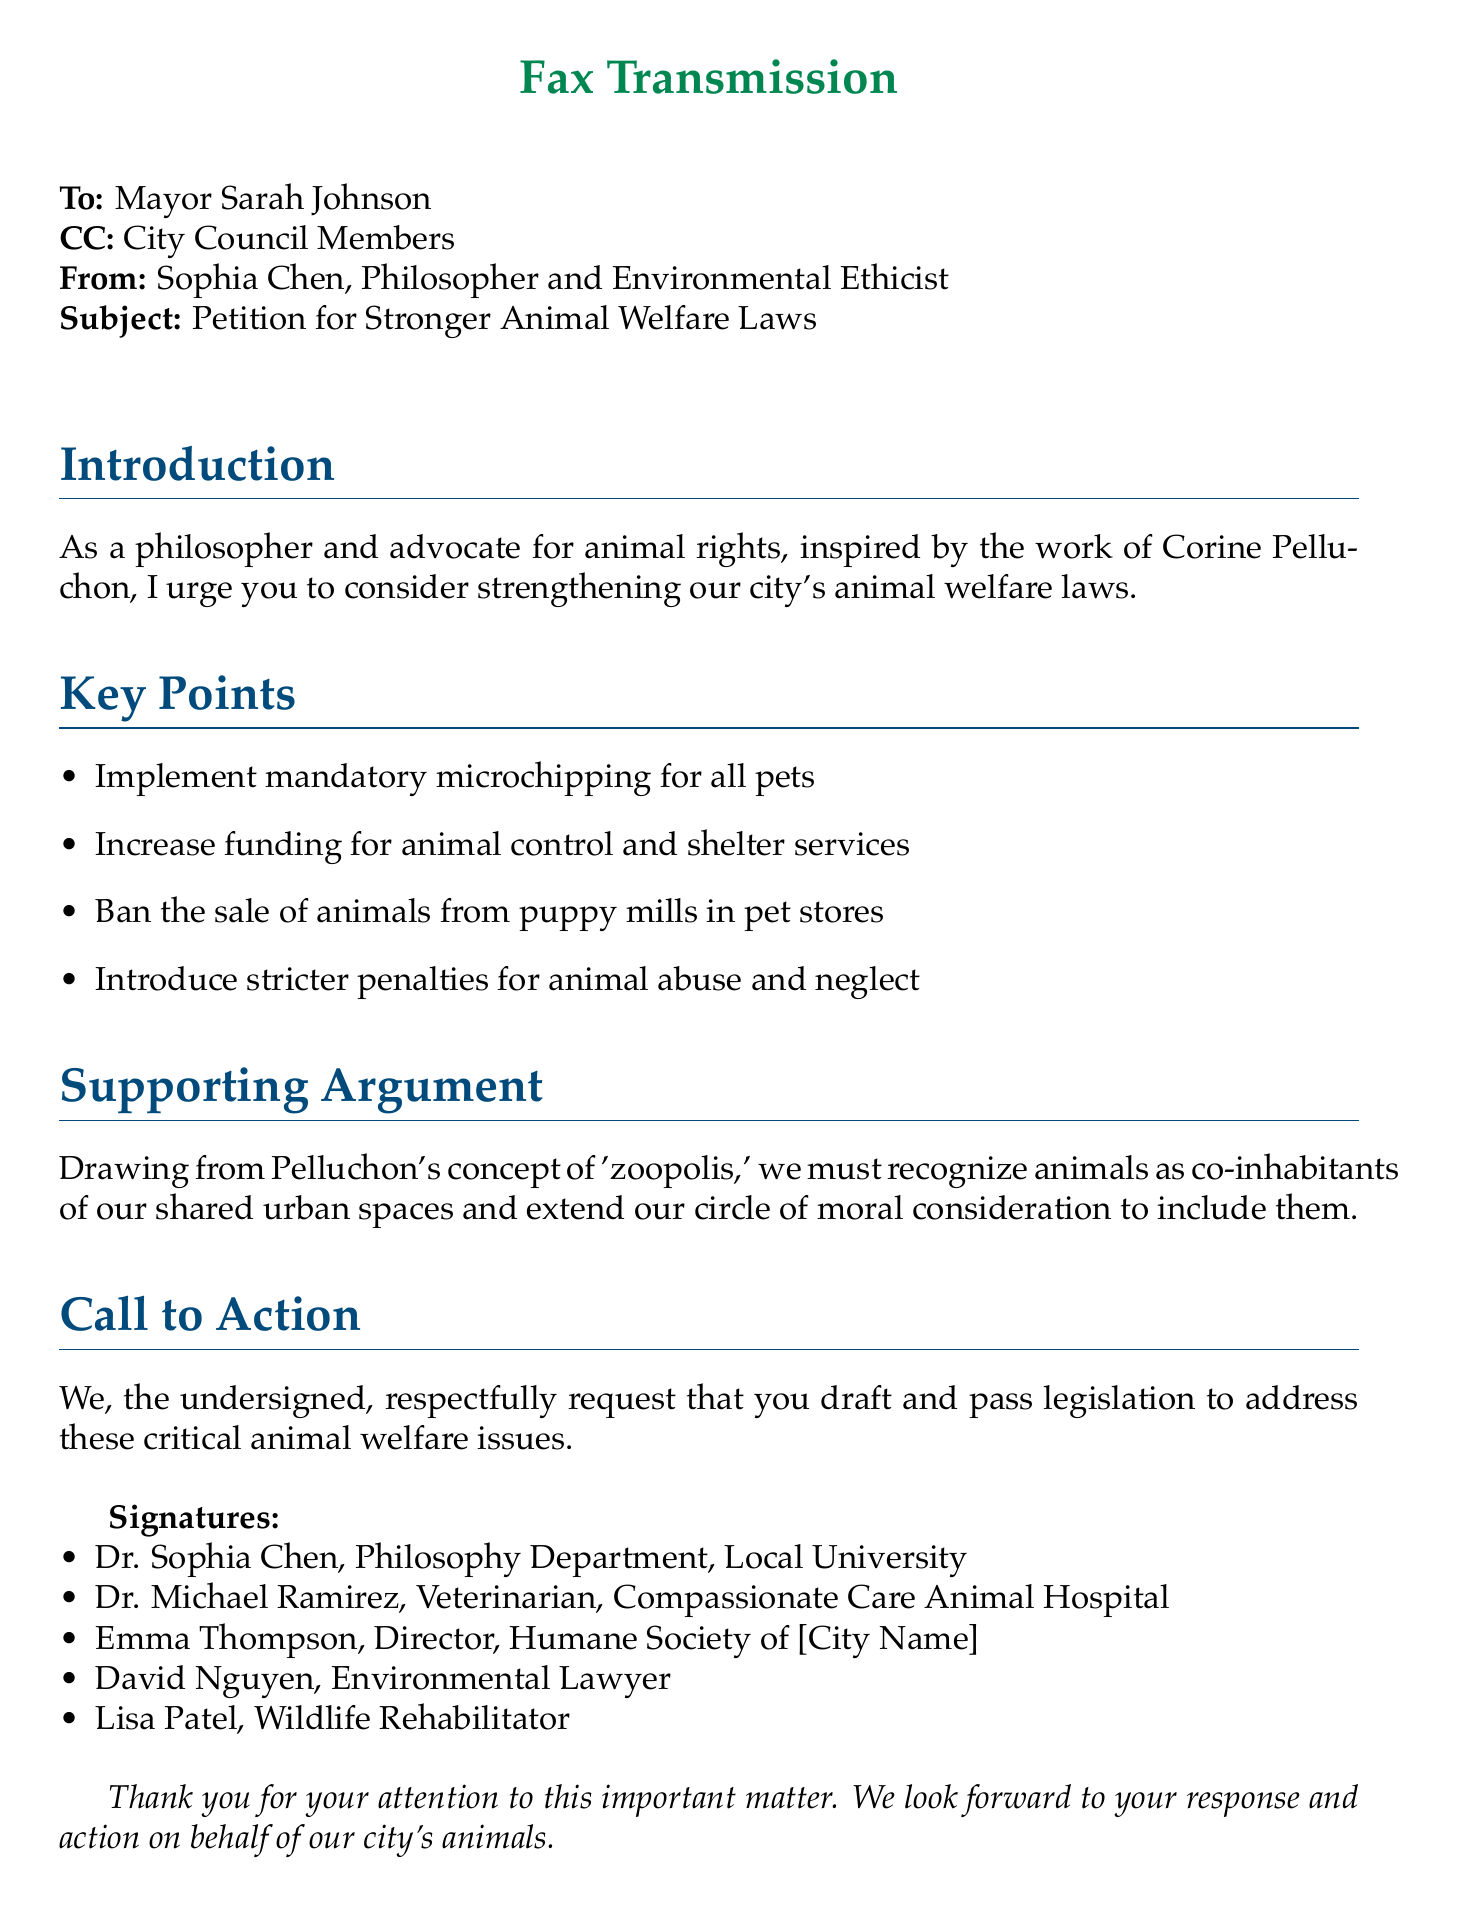What is the name of the sender? The sender's name is stated at the beginning of the document.
Answer: Sophia Chen Who is the recipient of the fax? The document specifically mentions the recipient in the "To" section.
Answer: Mayor Sarah Johnson What is one of the key points mentioned in the petition? The key points are listed in the "Key Points" section of the document.
Answer: Implement mandatory microchipping for all pets How many signatures are included in the petition? The signatures are listed at the end of the document, which indicates the total number.
Answer: Five What title does Dr. Michael Ramirez hold? The document provides specific titles for each individual who signed the petition.
Answer: Veterinarian What concept by Corine Pelluchon is referenced in the document? The document includes a reference to a specific term from Pelluchon's work to support the argument.
Answer: Zoopolis What is the purpose of the fax? The introduction clearly states the overall intent of the fax.
Answer: Petition for Stronger Animal Welfare Laws What action is being requested from the local government? The "Call to Action" section outlines the specific request being made.
Answer: Draft and pass legislation What organization does Emma Thompson represent? The document specifies the organization associated with one of the signatories.
Answer: Humane Society of [City Name] 